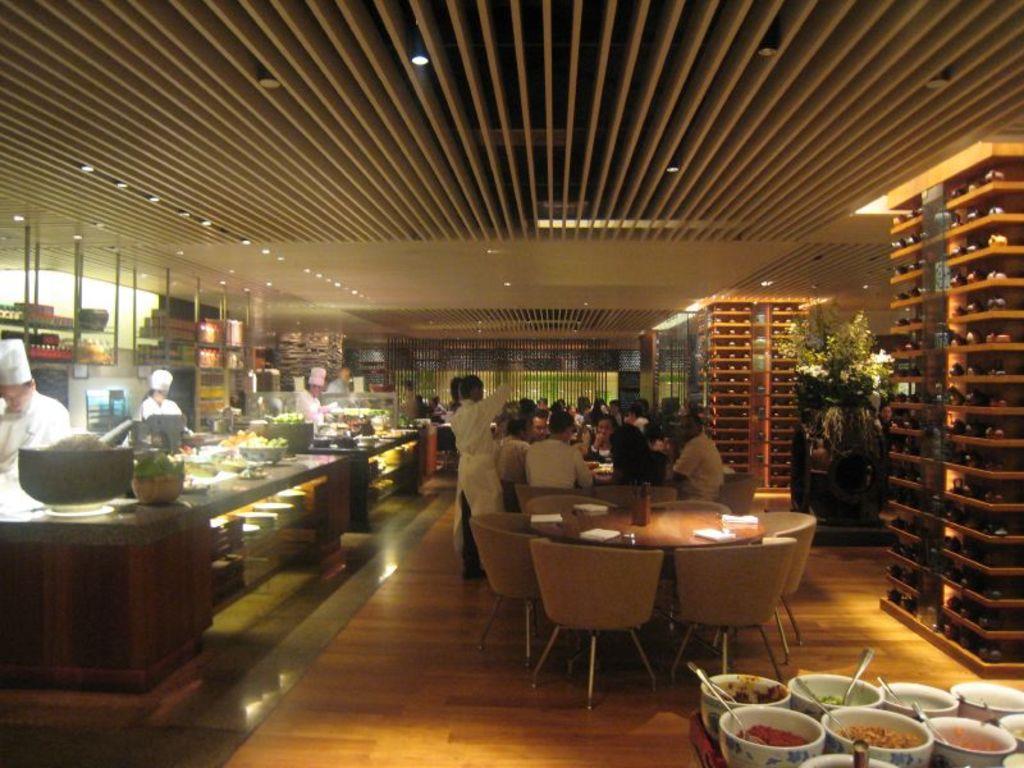Please provide a concise description of this image. In this image there are tables, on that tables there are few items, around the tables there are chairs, in that chairs there are people sitting, on the left side there are tables, on that tables there are food items, beside the table there are people standing, at the top there is a ceiling and there are lights. 